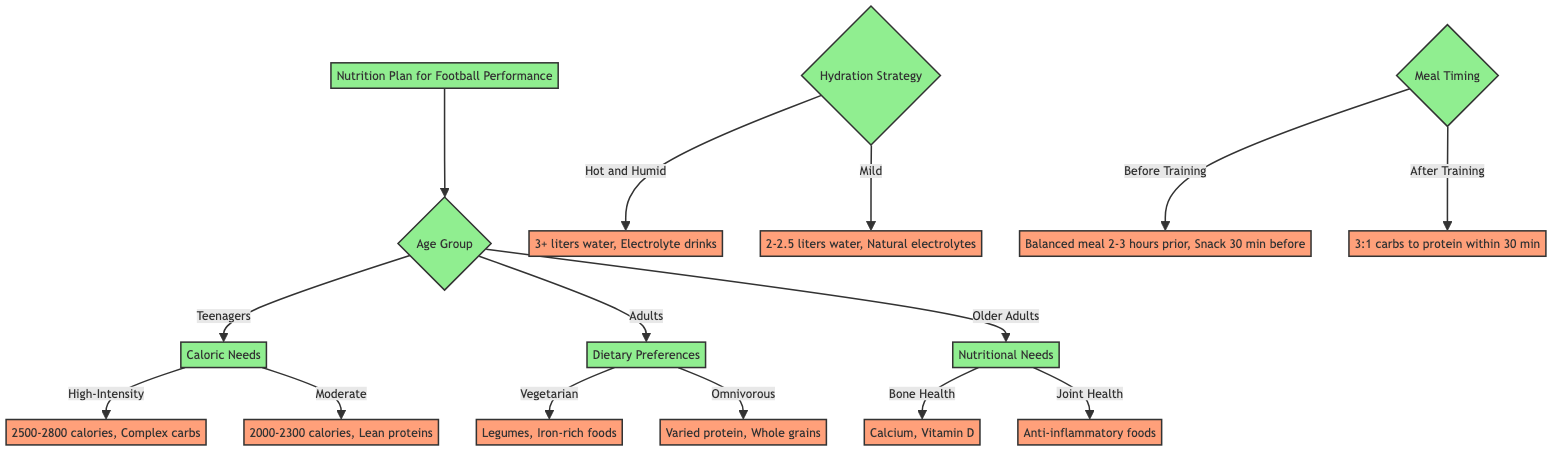What are the main criteria for deciding a nutrition plan in this diagram? The main criteria in the diagram are Age Group, Hydration Strategy, and Timing of Meals. Each of these categories branches out into more specific options.
Answer: Age Group, Hydration Strategy, Timing of Meals How many options are there under the Age Group criteria? Under the Age Group criteria, there are three options: Teenagers, Adults, and Older Adults. This can be counted directly from the branches listed under the Age Group node.
Answer: 3 What is the caloric recommendation for teenagers with high-intensity training? The diagram specifies that teenagers engaging in high-intensity training should consume between 2500 to 2800 calories daily. This information is found directly under the Teenagers and Caloric Needs branches.
Answer: 2500-2800 calories Which dietary choice for adults suggests the incorporation of protein-rich legumes? The Vegetarian option under the Dietary Preferences of Adults suggests incorporating protein-rich legumes like lentils and chickpeas. This is indicated in the description connected to the Vegetarian branch.
Answer: Vegetarian What is the hydration recommendation for hot and humid conditions? The recommendation for hot and humid conditions is to drink at least 3 liters of water daily and consider electrolyte-rich drinks like coconut water post-match, which is outlined under the Hydration Strategy node.
Answer: 3 liters of water What timing of meals is recommended before training? Before training, it is recommended to consume a balanced meal with carbohydrates, proteins, and fats 2-3 hours prior, along with a pre-training snack like a banana with peanut butter 30 minutes before. This is specified under the Timing of Meals section, linked to the Before Training choice.
Answer: Balanced meal 2-3 hours prior, Snack 30 minutes before How does the recommendation change based on the age group for joint health in older adults? For older adults focusing on joint health, the recommendation is to include anti-inflammatory foods like fatty fish (e.g., salmon) and use turmeric in cooking. This necessitates moving through the Older Adults and Nutritional Needs nodes to see the specifics.
Answer: Anti-inflammatory foods What is the ratio of carbohydrates to protein recommended after training? The diagram specifies a recovery meal with a 3:1 ratio of carbohydrates to protein within 30 minutes post-training, which is noted in the After Training branch of the Timing of Meals criteria.
Answer: 3:1 ratio 